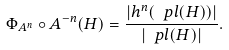<formula> <loc_0><loc_0><loc_500><loc_500>\Phi _ { A ^ { n } } \circ A ^ { - n } ( H ) = \frac { | h ^ { n } ( \ p l ( H ) ) | } { | \ p l ( H ) | } .</formula> 